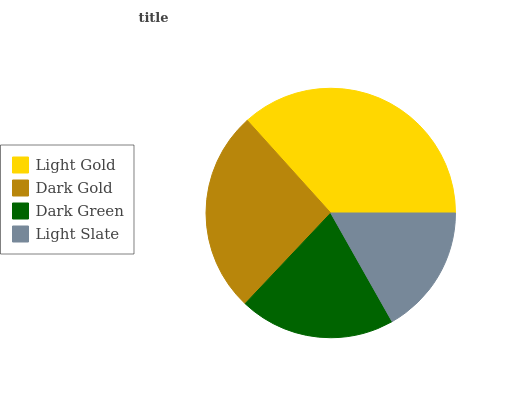Is Light Slate the minimum?
Answer yes or no. Yes. Is Light Gold the maximum?
Answer yes or no. Yes. Is Dark Gold the minimum?
Answer yes or no. No. Is Dark Gold the maximum?
Answer yes or no. No. Is Light Gold greater than Dark Gold?
Answer yes or no. Yes. Is Dark Gold less than Light Gold?
Answer yes or no. Yes. Is Dark Gold greater than Light Gold?
Answer yes or no. No. Is Light Gold less than Dark Gold?
Answer yes or no. No. Is Dark Gold the high median?
Answer yes or no. Yes. Is Dark Green the low median?
Answer yes or no. Yes. Is Light Slate the high median?
Answer yes or no. No. Is Light Slate the low median?
Answer yes or no. No. 